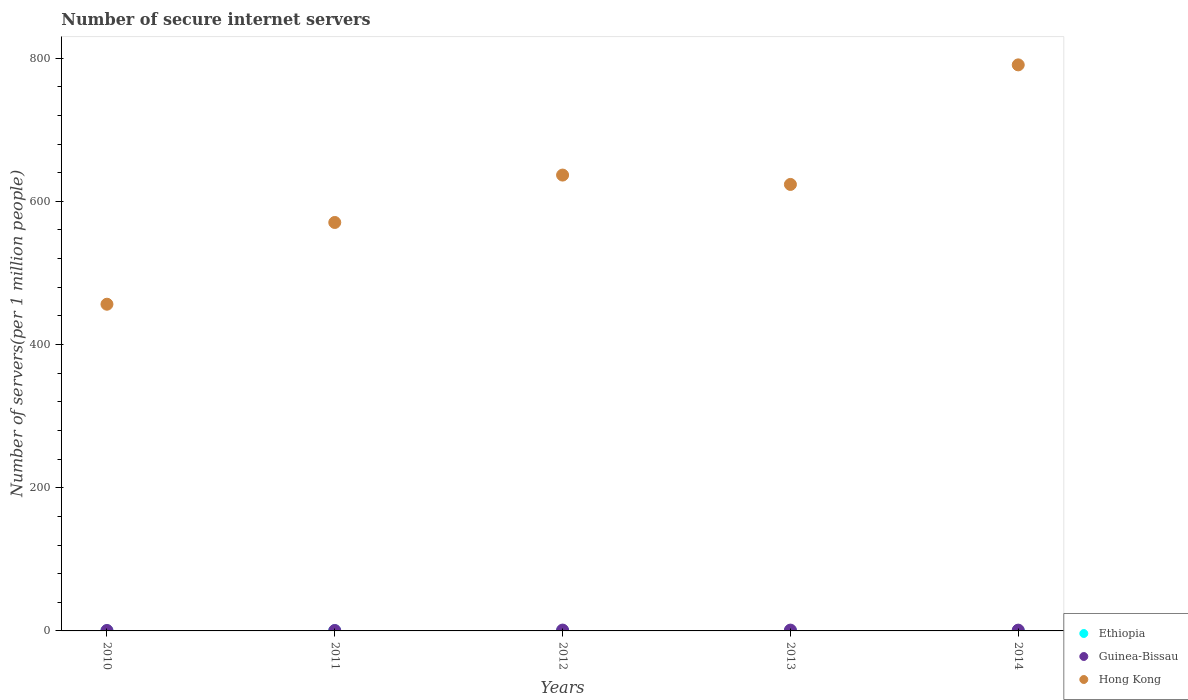How many different coloured dotlines are there?
Keep it short and to the point. 3. Is the number of dotlines equal to the number of legend labels?
Provide a succinct answer. Yes. What is the number of secure internet servers in Guinea-Bissau in 2014?
Your response must be concise. 1.11. Across all years, what is the maximum number of secure internet servers in Guinea-Bissau?
Your answer should be very brief. 1.17. Across all years, what is the minimum number of secure internet servers in Ethiopia?
Ensure brevity in your answer.  0.13. In which year was the number of secure internet servers in Guinea-Bissau minimum?
Make the answer very short. 2011. What is the total number of secure internet servers in Ethiopia in the graph?
Make the answer very short. 0.88. What is the difference between the number of secure internet servers in Guinea-Bissau in 2010 and that in 2013?
Offer a terse response. -0.53. What is the difference between the number of secure internet servers in Ethiopia in 2013 and the number of secure internet servers in Guinea-Bissau in 2014?
Keep it short and to the point. -0.94. What is the average number of secure internet servers in Guinea-Bissau per year?
Give a very brief answer. 0.92. In the year 2011, what is the difference between the number of secure internet servers in Ethiopia and number of secure internet servers in Hong Kong?
Offer a very short reply. -570.28. What is the ratio of the number of secure internet servers in Hong Kong in 2012 to that in 2014?
Offer a terse response. 0.81. Is the number of secure internet servers in Ethiopia in 2010 less than that in 2013?
Your answer should be compact. Yes. What is the difference between the highest and the second highest number of secure internet servers in Hong Kong?
Ensure brevity in your answer.  153.91. What is the difference between the highest and the lowest number of secure internet servers in Hong Kong?
Your answer should be compact. 334.28. In how many years, is the number of secure internet servers in Hong Kong greater than the average number of secure internet servers in Hong Kong taken over all years?
Your response must be concise. 3. Is the sum of the number of secure internet servers in Guinea-Bissau in 2010 and 2014 greater than the maximum number of secure internet servers in Hong Kong across all years?
Your response must be concise. No. Is it the case that in every year, the sum of the number of secure internet servers in Hong Kong and number of secure internet servers in Guinea-Bissau  is greater than the number of secure internet servers in Ethiopia?
Give a very brief answer. Yes. Is the number of secure internet servers in Guinea-Bissau strictly greater than the number of secure internet servers in Ethiopia over the years?
Keep it short and to the point. Yes. What is the difference between two consecutive major ticks on the Y-axis?
Give a very brief answer. 200. Are the values on the major ticks of Y-axis written in scientific E-notation?
Your answer should be compact. No. Does the graph contain grids?
Your response must be concise. No. How many legend labels are there?
Keep it short and to the point. 3. What is the title of the graph?
Give a very brief answer. Number of secure internet servers. Does "Bolivia" appear as one of the legend labels in the graph?
Offer a terse response. No. What is the label or title of the X-axis?
Offer a terse response. Years. What is the label or title of the Y-axis?
Your answer should be compact. Number of servers(per 1 million people). What is the Number of servers(per 1 million people) of Ethiopia in 2010?
Offer a terse response. 0.13. What is the Number of servers(per 1 million people) in Guinea-Bissau in 2010?
Your answer should be very brief. 0.61. What is the Number of servers(per 1 million people) of Hong Kong in 2010?
Provide a succinct answer. 456.28. What is the Number of servers(per 1 million people) in Ethiopia in 2011?
Provide a short and direct response. 0.17. What is the Number of servers(per 1 million people) of Guinea-Bissau in 2011?
Your answer should be very brief. 0.6. What is the Number of servers(per 1 million people) in Hong Kong in 2011?
Ensure brevity in your answer.  570.45. What is the Number of servers(per 1 million people) in Ethiopia in 2012?
Your answer should be compact. 0.2. What is the Number of servers(per 1 million people) in Guinea-Bissau in 2012?
Offer a terse response. 1.17. What is the Number of servers(per 1 million people) of Hong Kong in 2012?
Give a very brief answer. 636.65. What is the Number of servers(per 1 million people) of Ethiopia in 2013?
Your answer should be very brief. 0.17. What is the Number of servers(per 1 million people) in Guinea-Bissau in 2013?
Keep it short and to the point. 1.14. What is the Number of servers(per 1 million people) in Hong Kong in 2013?
Your response must be concise. 623.58. What is the Number of servers(per 1 million people) in Ethiopia in 2014?
Offer a very short reply. 0.23. What is the Number of servers(per 1 million people) of Guinea-Bissau in 2014?
Your answer should be compact. 1.11. What is the Number of servers(per 1 million people) in Hong Kong in 2014?
Provide a short and direct response. 790.56. Across all years, what is the maximum Number of servers(per 1 million people) in Ethiopia?
Provide a succinct answer. 0.23. Across all years, what is the maximum Number of servers(per 1 million people) in Guinea-Bissau?
Offer a very short reply. 1.17. Across all years, what is the maximum Number of servers(per 1 million people) of Hong Kong?
Your answer should be very brief. 790.56. Across all years, what is the minimum Number of servers(per 1 million people) in Ethiopia?
Your response must be concise. 0.13. Across all years, what is the minimum Number of servers(per 1 million people) of Guinea-Bissau?
Ensure brevity in your answer.  0.6. Across all years, what is the minimum Number of servers(per 1 million people) in Hong Kong?
Offer a terse response. 456.28. What is the total Number of servers(per 1 million people) of Ethiopia in the graph?
Ensure brevity in your answer.  0.88. What is the total Number of servers(per 1 million people) of Guinea-Bissau in the graph?
Provide a succinct answer. 4.62. What is the total Number of servers(per 1 million people) in Hong Kong in the graph?
Give a very brief answer. 3077.53. What is the difference between the Number of servers(per 1 million people) of Ethiopia in 2010 and that in 2011?
Your answer should be very brief. -0.04. What is the difference between the Number of servers(per 1 million people) in Guinea-Bissau in 2010 and that in 2011?
Your answer should be very brief. 0.01. What is the difference between the Number of servers(per 1 million people) in Hong Kong in 2010 and that in 2011?
Ensure brevity in your answer.  -114.17. What is the difference between the Number of servers(per 1 million people) in Ethiopia in 2010 and that in 2012?
Provide a succinct answer. -0.07. What is the difference between the Number of servers(per 1 million people) of Guinea-Bissau in 2010 and that in 2012?
Make the answer very short. -0.55. What is the difference between the Number of servers(per 1 million people) in Hong Kong in 2010 and that in 2012?
Make the answer very short. -180.37. What is the difference between the Number of servers(per 1 million people) of Ethiopia in 2010 and that in 2013?
Provide a succinct answer. -0.04. What is the difference between the Number of servers(per 1 million people) of Guinea-Bissau in 2010 and that in 2013?
Keep it short and to the point. -0.53. What is the difference between the Number of servers(per 1 million people) in Hong Kong in 2010 and that in 2013?
Provide a succinct answer. -167.3. What is the difference between the Number of servers(per 1 million people) of Ethiopia in 2010 and that in 2014?
Your answer should be compact. -0.1. What is the difference between the Number of servers(per 1 million people) of Guinea-Bissau in 2010 and that in 2014?
Your answer should be very brief. -0.5. What is the difference between the Number of servers(per 1 million people) of Hong Kong in 2010 and that in 2014?
Your response must be concise. -334.28. What is the difference between the Number of servers(per 1 million people) in Ethiopia in 2011 and that in 2012?
Give a very brief answer. -0.03. What is the difference between the Number of servers(per 1 million people) in Guinea-Bissau in 2011 and that in 2012?
Provide a succinct answer. -0.57. What is the difference between the Number of servers(per 1 million people) in Hong Kong in 2011 and that in 2012?
Provide a succinct answer. -66.2. What is the difference between the Number of servers(per 1 million people) of Ethiopia in 2011 and that in 2013?
Ensure brevity in your answer.  -0. What is the difference between the Number of servers(per 1 million people) of Guinea-Bissau in 2011 and that in 2013?
Your answer should be compact. -0.54. What is the difference between the Number of servers(per 1 million people) in Hong Kong in 2011 and that in 2013?
Give a very brief answer. -53.13. What is the difference between the Number of servers(per 1 million people) of Ethiopia in 2011 and that in 2014?
Offer a terse response. -0.06. What is the difference between the Number of servers(per 1 million people) of Guinea-Bissau in 2011 and that in 2014?
Provide a short and direct response. -0.51. What is the difference between the Number of servers(per 1 million people) in Hong Kong in 2011 and that in 2014?
Offer a very short reply. -220.11. What is the difference between the Number of servers(per 1 million people) in Ethiopia in 2012 and that in 2013?
Your answer should be very brief. 0.03. What is the difference between the Number of servers(per 1 million people) in Guinea-Bissau in 2012 and that in 2013?
Ensure brevity in your answer.  0.03. What is the difference between the Number of servers(per 1 million people) in Hong Kong in 2012 and that in 2013?
Offer a terse response. 13.07. What is the difference between the Number of servers(per 1 million people) in Ethiopia in 2012 and that in 2014?
Your answer should be very brief. -0.03. What is the difference between the Number of servers(per 1 million people) of Guinea-Bissau in 2012 and that in 2014?
Offer a terse response. 0.06. What is the difference between the Number of servers(per 1 million people) in Hong Kong in 2012 and that in 2014?
Provide a succinct answer. -153.91. What is the difference between the Number of servers(per 1 million people) in Ethiopia in 2013 and that in 2014?
Make the answer very short. -0.06. What is the difference between the Number of servers(per 1 million people) of Guinea-Bissau in 2013 and that in 2014?
Your answer should be very brief. 0.03. What is the difference between the Number of servers(per 1 million people) of Hong Kong in 2013 and that in 2014?
Ensure brevity in your answer.  -166.98. What is the difference between the Number of servers(per 1 million people) in Ethiopia in 2010 and the Number of servers(per 1 million people) in Guinea-Bissau in 2011?
Give a very brief answer. -0.47. What is the difference between the Number of servers(per 1 million people) of Ethiopia in 2010 and the Number of servers(per 1 million people) of Hong Kong in 2011?
Provide a succinct answer. -570.33. What is the difference between the Number of servers(per 1 million people) of Guinea-Bissau in 2010 and the Number of servers(per 1 million people) of Hong Kong in 2011?
Provide a short and direct response. -569.84. What is the difference between the Number of servers(per 1 million people) in Ethiopia in 2010 and the Number of servers(per 1 million people) in Guinea-Bissau in 2012?
Provide a succinct answer. -1.04. What is the difference between the Number of servers(per 1 million people) in Ethiopia in 2010 and the Number of servers(per 1 million people) in Hong Kong in 2012?
Provide a short and direct response. -636.53. What is the difference between the Number of servers(per 1 million people) in Guinea-Bissau in 2010 and the Number of servers(per 1 million people) in Hong Kong in 2012?
Offer a very short reply. -636.04. What is the difference between the Number of servers(per 1 million people) in Ethiopia in 2010 and the Number of servers(per 1 million people) in Guinea-Bissau in 2013?
Your response must be concise. -1.01. What is the difference between the Number of servers(per 1 million people) in Ethiopia in 2010 and the Number of servers(per 1 million people) in Hong Kong in 2013?
Your response must be concise. -623.46. What is the difference between the Number of servers(per 1 million people) in Guinea-Bissau in 2010 and the Number of servers(per 1 million people) in Hong Kong in 2013?
Provide a succinct answer. -622.97. What is the difference between the Number of servers(per 1 million people) in Ethiopia in 2010 and the Number of servers(per 1 million people) in Guinea-Bissau in 2014?
Make the answer very short. -0.99. What is the difference between the Number of servers(per 1 million people) in Ethiopia in 2010 and the Number of servers(per 1 million people) in Hong Kong in 2014?
Offer a very short reply. -790.43. What is the difference between the Number of servers(per 1 million people) of Guinea-Bissau in 2010 and the Number of servers(per 1 million people) of Hong Kong in 2014?
Keep it short and to the point. -789.95. What is the difference between the Number of servers(per 1 million people) of Ethiopia in 2011 and the Number of servers(per 1 million people) of Guinea-Bissau in 2012?
Keep it short and to the point. -1. What is the difference between the Number of servers(per 1 million people) of Ethiopia in 2011 and the Number of servers(per 1 million people) of Hong Kong in 2012?
Give a very brief answer. -636.49. What is the difference between the Number of servers(per 1 million people) in Guinea-Bissau in 2011 and the Number of servers(per 1 million people) in Hong Kong in 2012?
Offer a very short reply. -636.06. What is the difference between the Number of servers(per 1 million people) in Ethiopia in 2011 and the Number of servers(per 1 million people) in Guinea-Bissau in 2013?
Provide a succinct answer. -0.97. What is the difference between the Number of servers(per 1 million people) in Ethiopia in 2011 and the Number of servers(per 1 million people) in Hong Kong in 2013?
Your answer should be compact. -623.42. What is the difference between the Number of servers(per 1 million people) in Guinea-Bissau in 2011 and the Number of servers(per 1 million people) in Hong Kong in 2013?
Provide a short and direct response. -622.99. What is the difference between the Number of servers(per 1 million people) in Ethiopia in 2011 and the Number of servers(per 1 million people) in Guinea-Bissau in 2014?
Ensure brevity in your answer.  -0.94. What is the difference between the Number of servers(per 1 million people) of Ethiopia in 2011 and the Number of servers(per 1 million people) of Hong Kong in 2014?
Your response must be concise. -790.39. What is the difference between the Number of servers(per 1 million people) of Guinea-Bissau in 2011 and the Number of servers(per 1 million people) of Hong Kong in 2014?
Offer a terse response. -789.96. What is the difference between the Number of servers(per 1 million people) in Ethiopia in 2012 and the Number of servers(per 1 million people) in Guinea-Bissau in 2013?
Offer a terse response. -0.94. What is the difference between the Number of servers(per 1 million people) of Ethiopia in 2012 and the Number of servers(per 1 million people) of Hong Kong in 2013?
Provide a short and direct response. -623.39. What is the difference between the Number of servers(per 1 million people) in Guinea-Bissau in 2012 and the Number of servers(per 1 million people) in Hong Kong in 2013?
Give a very brief answer. -622.42. What is the difference between the Number of servers(per 1 million people) in Ethiopia in 2012 and the Number of servers(per 1 million people) in Guinea-Bissau in 2014?
Your response must be concise. -0.92. What is the difference between the Number of servers(per 1 million people) of Ethiopia in 2012 and the Number of servers(per 1 million people) of Hong Kong in 2014?
Make the answer very short. -790.37. What is the difference between the Number of servers(per 1 million people) of Guinea-Bissau in 2012 and the Number of servers(per 1 million people) of Hong Kong in 2014?
Your response must be concise. -789.39. What is the difference between the Number of servers(per 1 million people) in Ethiopia in 2013 and the Number of servers(per 1 million people) in Guinea-Bissau in 2014?
Provide a succinct answer. -0.94. What is the difference between the Number of servers(per 1 million people) in Ethiopia in 2013 and the Number of servers(per 1 million people) in Hong Kong in 2014?
Ensure brevity in your answer.  -790.39. What is the difference between the Number of servers(per 1 million people) in Guinea-Bissau in 2013 and the Number of servers(per 1 million people) in Hong Kong in 2014?
Give a very brief answer. -789.42. What is the average Number of servers(per 1 million people) in Ethiopia per year?
Give a very brief answer. 0.18. What is the average Number of servers(per 1 million people) of Guinea-Bissau per year?
Your answer should be compact. 0.93. What is the average Number of servers(per 1 million people) of Hong Kong per year?
Offer a very short reply. 615.51. In the year 2010, what is the difference between the Number of servers(per 1 million people) of Ethiopia and Number of servers(per 1 million people) of Guinea-Bissau?
Keep it short and to the point. -0.49. In the year 2010, what is the difference between the Number of servers(per 1 million people) in Ethiopia and Number of servers(per 1 million people) in Hong Kong?
Your answer should be very brief. -456.15. In the year 2010, what is the difference between the Number of servers(per 1 million people) in Guinea-Bissau and Number of servers(per 1 million people) in Hong Kong?
Ensure brevity in your answer.  -455.67. In the year 2011, what is the difference between the Number of servers(per 1 million people) of Ethiopia and Number of servers(per 1 million people) of Guinea-Bissau?
Make the answer very short. -0.43. In the year 2011, what is the difference between the Number of servers(per 1 million people) in Ethiopia and Number of servers(per 1 million people) in Hong Kong?
Give a very brief answer. -570.28. In the year 2011, what is the difference between the Number of servers(per 1 million people) of Guinea-Bissau and Number of servers(per 1 million people) of Hong Kong?
Offer a very short reply. -569.85. In the year 2012, what is the difference between the Number of servers(per 1 million people) of Ethiopia and Number of servers(per 1 million people) of Guinea-Bissau?
Give a very brief answer. -0.97. In the year 2012, what is the difference between the Number of servers(per 1 million people) of Ethiopia and Number of servers(per 1 million people) of Hong Kong?
Provide a short and direct response. -636.46. In the year 2012, what is the difference between the Number of servers(per 1 million people) of Guinea-Bissau and Number of servers(per 1 million people) of Hong Kong?
Your response must be concise. -635.49. In the year 2013, what is the difference between the Number of servers(per 1 million people) of Ethiopia and Number of servers(per 1 million people) of Guinea-Bissau?
Keep it short and to the point. -0.97. In the year 2013, what is the difference between the Number of servers(per 1 million people) of Ethiopia and Number of servers(per 1 million people) of Hong Kong?
Give a very brief answer. -623.41. In the year 2013, what is the difference between the Number of servers(per 1 million people) of Guinea-Bissau and Number of servers(per 1 million people) of Hong Kong?
Offer a very short reply. -622.44. In the year 2014, what is the difference between the Number of servers(per 1 million people) in Ethiopia and Number of servers(per 1 million people) in Guinea-Bissau?
Provide a succinct answer. -0.88. In the year 2014, what is the difference between the Number of servers(per 1 million people) in Ethiopia and Number of servers(per 1 million people) in Hong Kong?
Your answer should be very brief. -790.33. In the year 2014, what is the difference between the Number of servers(per 1 million people) of Guinea-Bissau and Number of servers(per 1 million people) of Hong Kong?
Your answer should be very brief. -789.45. What is the ratio of the Number of servers(per 1 million people) in Ethiopia in 2010 to that in 2011?
Offer a terse response. 0.75. What is the ratio of the Number of servers(per 1 million people) of Guinea-Bissau in 2010 to that in 2011?
Give a very brief answer. 1.02. What is the ratio of the Number of servers(per 1 million people) in Hong Kong in 2010 to that in 2011?
Make the answer very short. 0.8. What is the ratio of the Number of servers(per 1 million people) in Ethiopia in 2010 to that in 2012?
Provide a short and direct response. 0.64. What is the ratio of the Number of servers(per 1 million people) of Guinea-Bissau in 2010 to that in 2012?
Keep it short and to the point. 0.52. What is the ratio of the Number of servers(per 1 million people) of Hong Kong in 2010 to that in 2012?
Provide a succinct answer. 0.72. What is the ratio of the Number of servers(per 1 million people) in Ethiopia in 2010 to that in 2013?
Your answer should be very brief. 0.74. What is the ratio of the Number of servers(per 1 million people) of Guinea-Bissau in 2010 to that in 2013?
Keep it short and to the point. 0.54. What is the ratio of the Number of servers(per 1 million people) of Hong Kong in 2010 to that in 2013?
Your answer should be compact. 0.73. What is the ratio of the Number of servers(per 1 million people) of Ethiopia in 2010 to that in 2014?
Provide a succinct answer. 0.55. What is the ratio of the Number of servers(per 1 million people) in Guinea-Bissau in 2010 to that in 2014?
Your answer should be compact. 0.55. What is the ratio of the Number of servers(per 1 million people) of Hong Kong in 2010 to that in 2014?
Keep it short and to the point. 0.58. What is the ratio of the Number of servers(per 1 million people) in Ethiopia in 2011 to that in 2012?
Your answer should be very brief. 0.85. What is the ratio of the Number of servers(per 1 million people) of Guinea-Bissau in 2011 to that in 2012?
Provide a succinct answer. 0.51. What is the ratio of the Number of servers(per 1 million people) in Hong Kong in 2011 to that in 2012?
Provide a succinct answer. 0.9. What is the ratio of the Number of servers(per 1 million people) of Ethiopia in 2011 to that in 2013?
Your response must be concise. 0.99. What is the ratio of the Number of servers(per 1 million people) of Guinea-Bissau in 2011 to that in 2013?
Keep it short and to the point. 0.53. What is the ratio of the Number of servers(per 1 million people) of Hong Kong in 2011 to that in 2013?
Offer a very short reply. 0.91. What is the ratio of the Number of servers(per 1 million people) of Ethiopia in 2011 to that in 2014?
Your answer should be very brief. 0.74. What is the ratio of the Number of servers(per 1 million people) of Guinea-Bissau in 2011 to that in 2014?
Offer a terse response. 0.54. What is the ratio of the Number of servers(per 1 million people) of Hong Kong in 2011 to that in 2014?
Your response must be concise. 0.72. What is the ratio of the Number of servers(per 1 million people) of Ethiopia in 2012 to that in 2013?
Offer a terse response. 1.15. What is the ratio of the Number of servers(per 1 million people) in Guinea-Bissau in 2012 to that in 2013?
Provide a succinct answer. 1.02. What is the ratio of the Number of servers(per 1 million people) in Ethiopia in 2012 to that in 2014?
Provide a succinct answer. 0.86. What is the ratio of the Number of servers(per 1 million people) in Guinea-Bissau in 2012 to that in 2014?
Offer a very short reply. 1.05. What is the ratio of the Number of servers(per 1 million people) of Hong Kong in 2012 to that in 2014?
Your answer should be compact. 0.81. What is the ratio of the Number of servers(per 1 million people) of Ethiopia in 2013 to that in 2014?
Your answer should be very brief. 0.75. What is the ratio of the Number of servers(per 1 million people) in Guinea-Bissau in 2013 to that in 2014?
Ensure brevity in your answer.  1.02. What is the ratio of the Number of servers(per 1 million people) of Hong Kong in 2013 to that in 2014?
Ensure brevity in your answer.  0.79. What is the difference between the highest and the second highest Number of servers(per 1 million people) of Ethiopia?
Provide a succinct answer. 0.03. What is the difference between the highest and the second highest Number of servers(per 1 million people) of Guinea-Bissau?
Your answer should be very brief. 0.03. What is the difference between the highest and the second highest Number of servers(per 1 million people) of Hong Kong?
Offer a terse response. 153.91. What is the difference between the highest and the lowest Number of servers(per 1 million people) of Ethiopia?
Ensure brevity in your answer.  0.1. What is the difference between the highest and the lowest Number of servers(per 1 million people) in Guinea-Bissau?
Ensure brevity in your answer.  0.57. What is the difference between the highest and the lowest Number of servers(per 1 million people) of Hong Kong?
Ensure brevity in your answer.  334.28. 